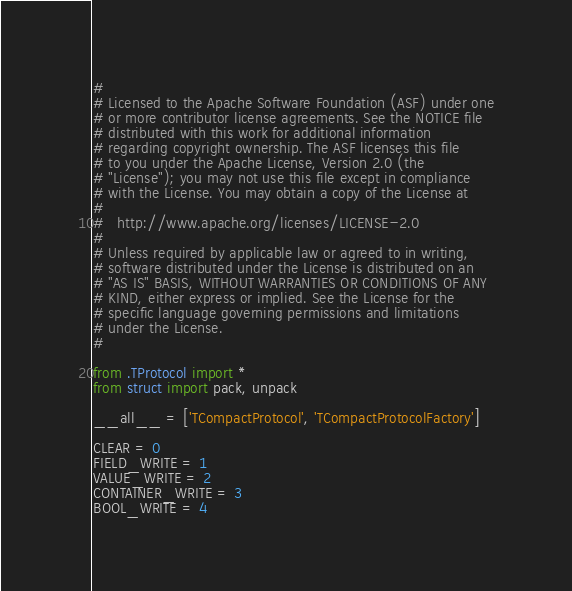Convert code to text. <code><loc_0><loc_0><loc_500><loc_500><_Python_>#
# Licensed to the Apache Software Foundation (ASF) under one
# or more contributor license agreements. See the NOTICE file
# distributed with this work for additional information
# regarding copyright ownership. The ASF licenses this file
# to you under the Apache License, Version 2.0 (the
# "License"); you may not use this file except in compliance
# with the License. You may obtain a copy of the License at
#
#   http://www.apache.org/licenses/LICENSE-2.0
#
# Unless required by applicable law or agreed to in writing,
# software distributed under the License is distributed on an
# "AS IS" BASIS, WITHOUT WARRANTIES OR CONDITIONS OF ANY
# KIND, either express or implied. See the License for the
# specific language governing permissions and limitations
# under the License.
#

from .TProtocol import *
from struct import pack, unpack

__all__ = ['TCompactProtocol', 'TCompactProtocolFactory']

CLEAR = 0
FIELD_WRITE = 1
VALUE_WRITE = 2
CONTAINER_WRITE = 3
BOOL_WRITE = 4</code> 